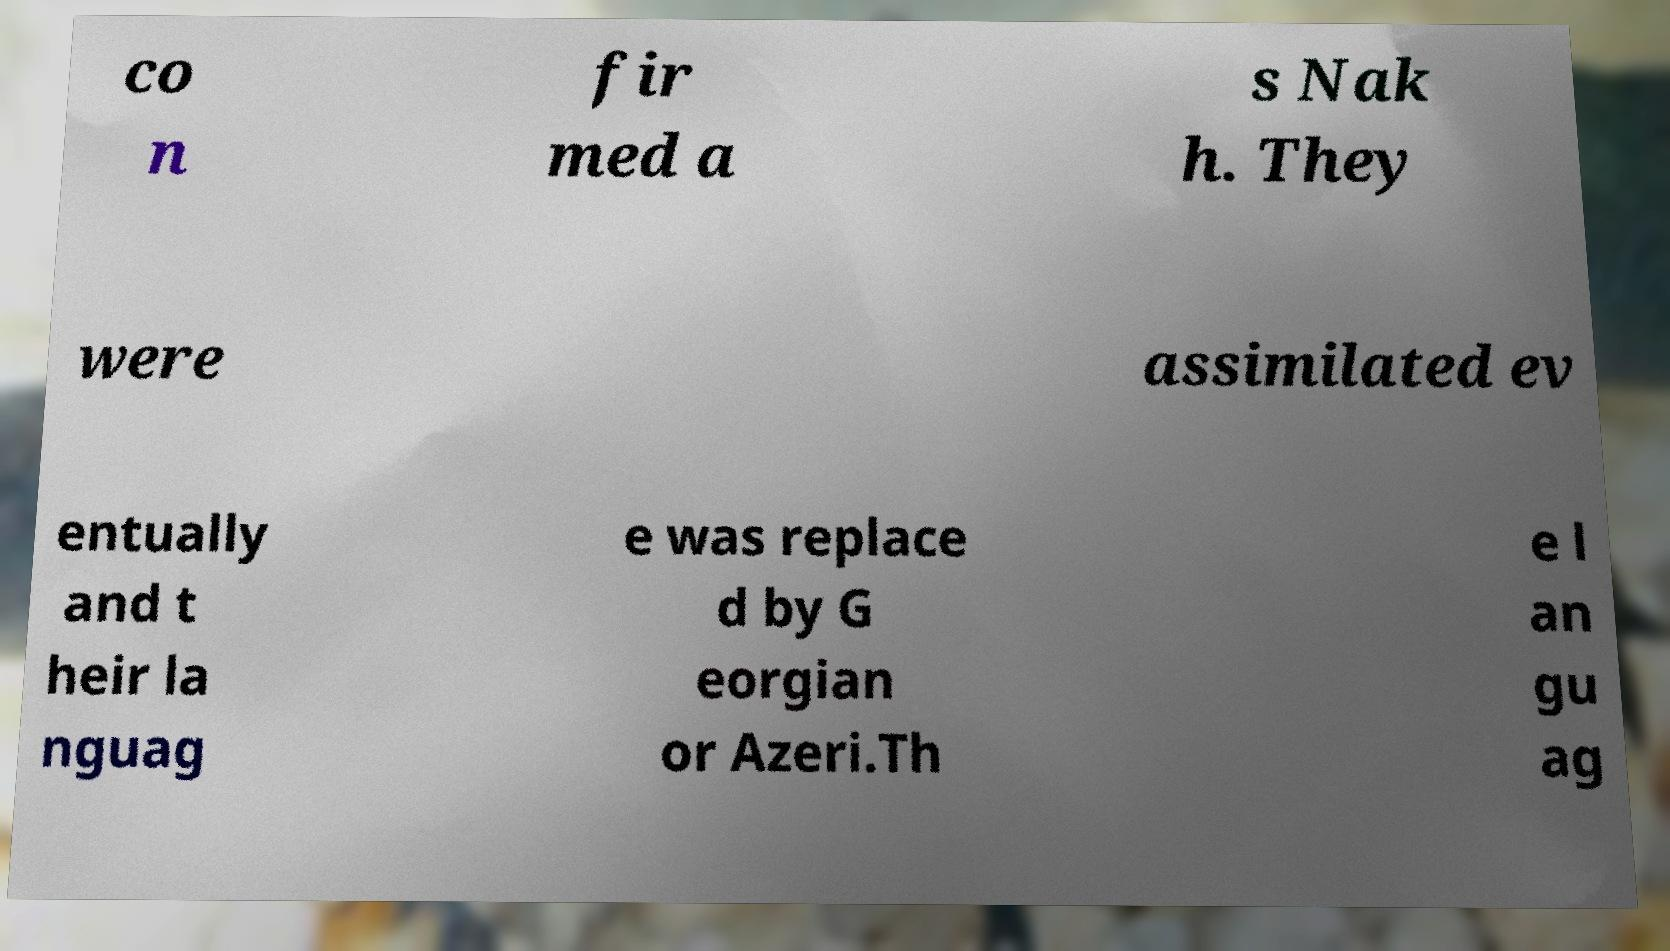Could you assist in decoding the text presented in this image and type it out clearly? co n fir med a s Nak h. They were assimilated ev entually and t heir la nguag e was replace d by G eorgian or Azeri.Th e l an gu ag 